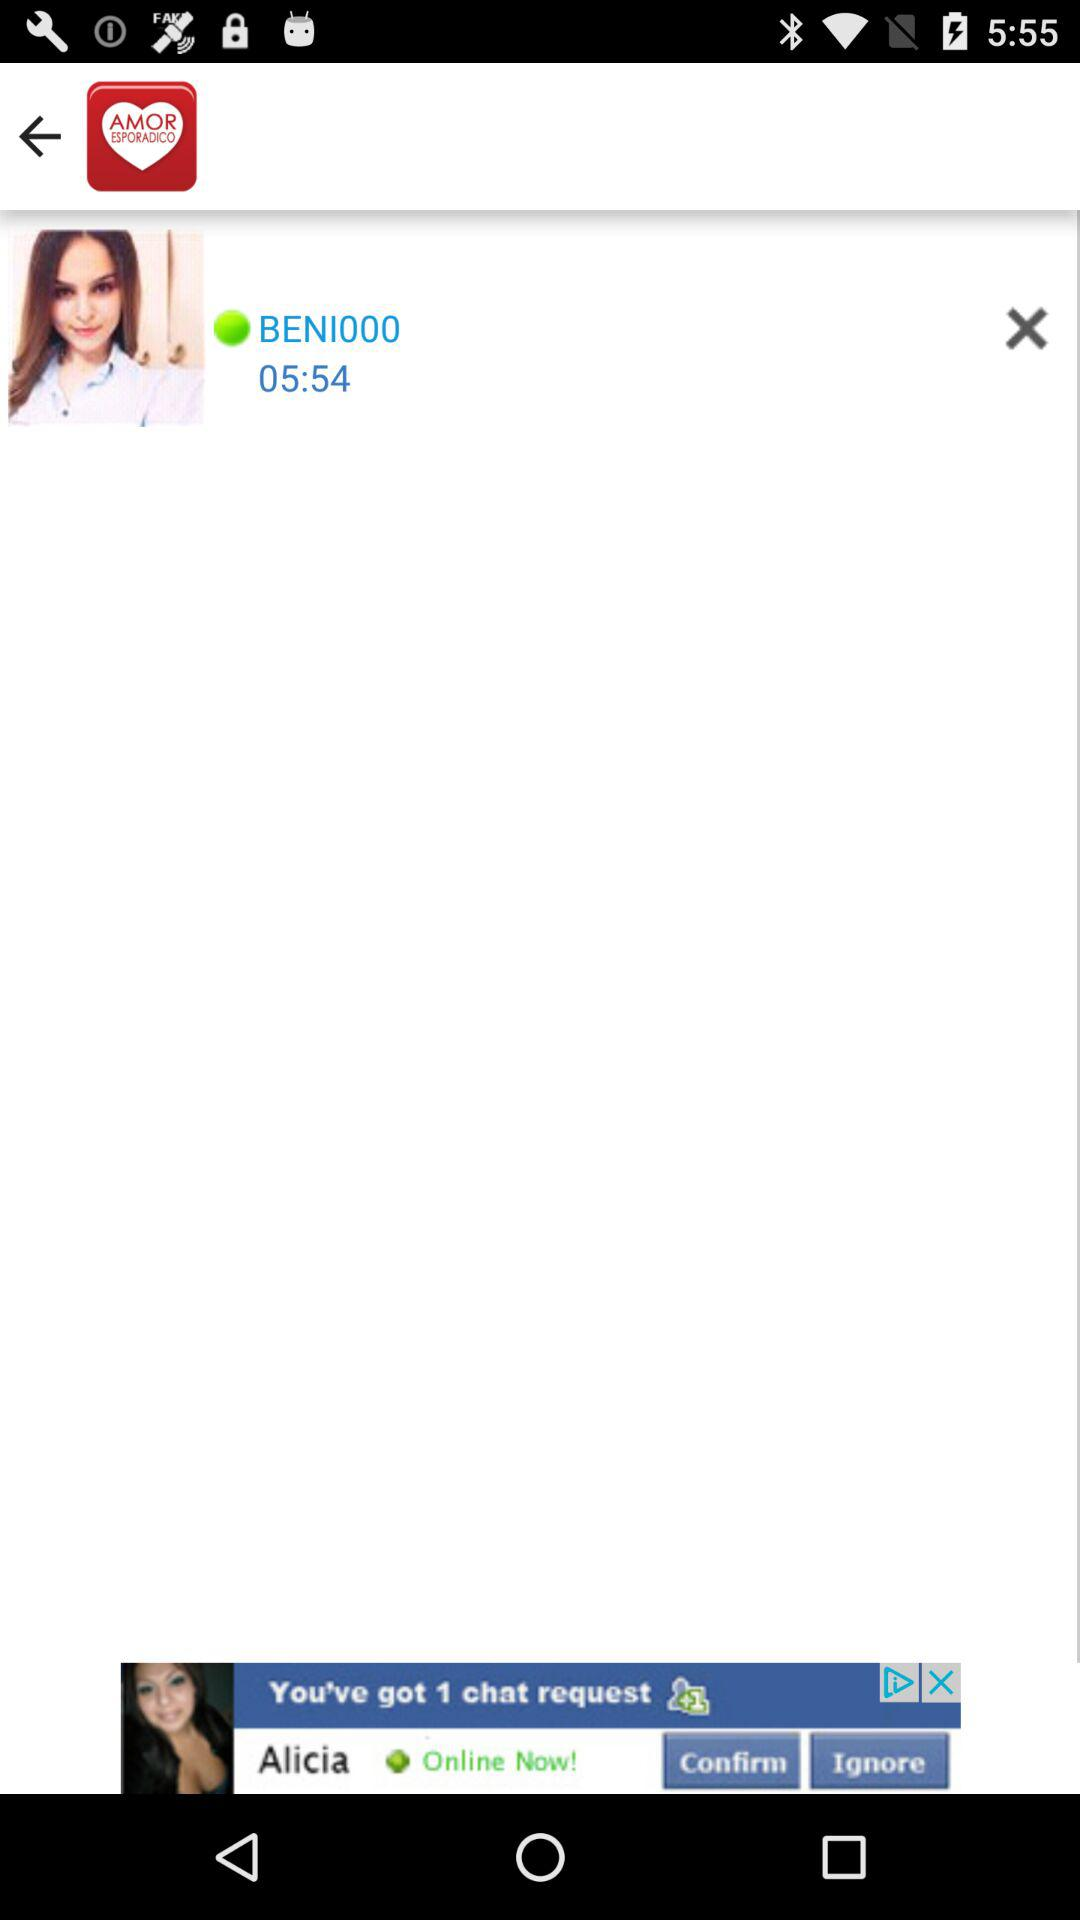What is the name of the application? The name of the application is "AmorEsporadico buscar pareja". 